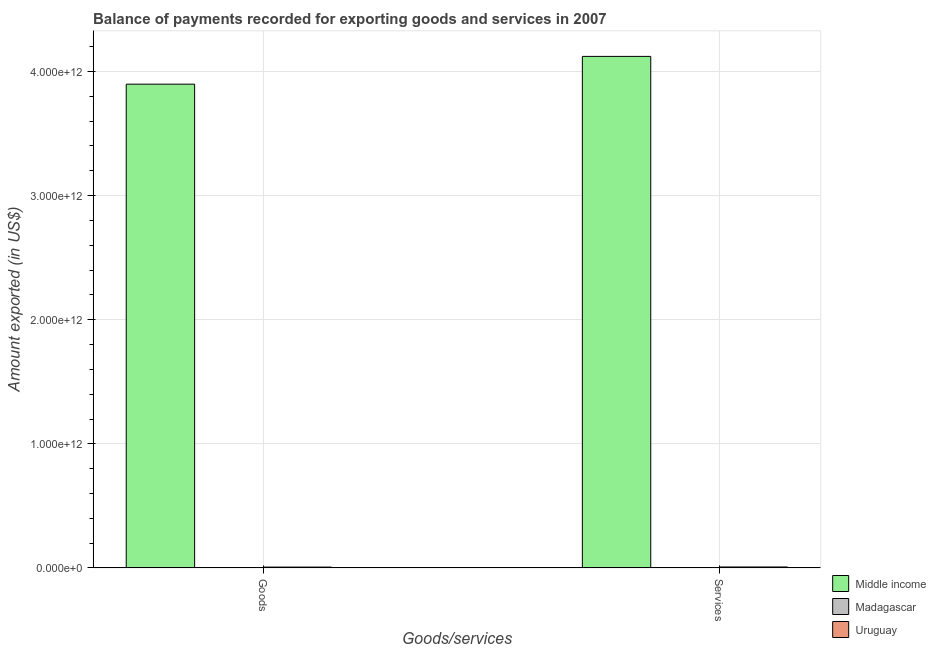How many groups of bars are there?
Your response must be concise. 2. Are the number of bars per tick equal to the number of legend labels?
Give a very brief answer. Yes. Are the number of bars on each tick of the X-axis equal?
Your answer should be very brief. Yes. How many bars are there on the 1st tick from the right?
Keep it short and to the point. 3. What is the label of the 1st group of bars from the left?
Your answer should be very brief. Goods. What is the amount of goods exported in Middle income?
Keep it short and to the point. 3.90e+12. Across all countries, what is the maximum amount of services exported?
Make the answer very short. 4.12e+12. Across all countries, what is the minimum amount of services exported?
Provide a short and direct response. 2.30e+09. In which country was the amount of goods exported maximum?
Your answer should be compact. Middle income. In which country was the amount of goods exported minimum?
Your answer should be compact. Madagascar. What is the total amount of goods exported in the graph?
Your response must be concise. 3.91e+12. What is the difference between the amount of goods exported in Uruguay and that in Middle income?
Your response must be concise. -3.89e+12. What is the difference between the amount of services exported in Middle income and the amount of goods exported in Madagascar?
Provide a short and direct response. 4.12e+12. What is the average amount of services exported per country?
Make the answer very short. 1.38e+12. What is the difference between the amount of services exported and amount of goods exported in Madagascar?
Provide a short and direct response. 5.18e+07. In how many countries, is the amount of goods exported greater than 2800000000000 US$?
Give a very brief answer. 1. What is the ratio of the amount of services exported in Madagascar to that in Uruguay?
Offer a very short reply. 0.29. Is the amount of services exported in Middle income less than that in Madagascar?
Your response must be concise. No. In how many countries, is the amount of goods exported greater than the average amount of goods exported taken over all countries?
Make the answer very short. 1. What does the 1st bar from the left in Services represents?
Give a very brief answer. Middle income. What does the 2nd bar from the right in Goods represents?
Provide a succinct answer. Madagascar. How many countries are there in the graph?
Provide a short and direct response. 3. What is the difference between two consecutive major ticks on the Y-axis?
Keep it short and to the point. 1.00e+12. Are the values on the major ticks of Y-axis written in scientific E-notation?
Provide a succinct answer. Yes. Where does the legend appear in the graph?
Ensure brevity in your answer.  Bottom right. How many legend labels are there?
Your answer should be very brief. 3. What is the title of the graph?
Provide a short and direct response. Balance of payments recorded for exporting goods and services in 2007. What is the label or title of the X-axis?
Give a very brief answer. Goods/services. What is the label or title of the Y-axis?
Your answer should be very brief. Amount exported (in US$). What is the Amount exported (in US$) in Middle income in Goods?
Give a very brief answer. 3.90e+12. What is the Amount exported (in US$) of Madagascar in Goods?
Offer a terse response. 2.24e+09. What is the Amount exported (in US$) of Uruguay in Goods?
Your answer should be compact. 6.93e+09. What is the Amount exported (in US$) of Middle income in Services?
Ensure brevity in your answer.  4.12e+12. What is the Amount exported (in US$) of Madagascar in Services?
Your answer should be very brief. 2.30e+09. What is the Amount exported (in US$) of Uruguay in Services?
Offer a terse response. 7.82e+09. Across all Goods/services, what is the maximum Amount exported (in US$) of Middle income?
Provide a succinct answer. 4.12e+12. Across all Goods/services, what is the maximum Amount exported (in US$) of Madagascar?
Provide a short and direct response. 2.30e+09. Across all Goods/services, what is the maximum Amount exported (in US$) of Uruguay?
Give a very brief answer. 7.82e+09. Across all Goods/services, what is the minimum Amount exported (in US$) of Middle income?
Keep it short and to the point. 3.90e+12. Across all Goods/services, what is the minimum Amount exported (in US$) of Madagascar?
Your response must be concise. 2.24e+09. Across all Goods/services, what is the minimum Amount exported (in US$) in Uruguay?
Offer a terse response. 6.93e+09. What is the total Amount exported (in US$) in Middle income in the graph?
Offer a very short reply. 8.02e+12. What is the total Amount exported (in US$) of Madagascar in the graph?
Provide a succinct answer. 4.54e+09. What is the total Amount exported (in US$) of Uruguay in the graph?
Offer a terse response. 1.48e+1. What is the difference between the Amount exported (in US$) of Middle income in Goods and that in Services?
Offer a very short reply. -2.24e+11. What is the difference between the Amount exported (in US$) of Madagascar in Goods and that in Services?
Make the answer very short. -5.18e+07. What is the difference between the Amount exported (in US$) in Uruguay in Goods and that in Services?
Offer a terse response. -8.85e+08. What is the difference between the Amount exported (in US$) of Middle income in Goods and the Amount exported (in US$) of Madagascar in Services?
Your answer should be very brief. 3.90e+12. What is the difference between the Amount exported (in US$) of Middle income in Goods and the Amount exported (in US$) of Uruguay in Services?
Provide a succinct answer. 3.89e+12. What is the difference between the Amount exported (in US$) in Madagascar in Goods and the Amount exported (in US$) in Uruguay in Services?
Provide a succinct answer. -5.57e+09. What is the average Amount exported (in US$) of Middle income per Goods/services?
Provide a succinct answer. 4.01e+12. What is the average Amount exported (in US$) in Madagascar per Goods/services?
Your answer should be compact. 2.27e+09. What is the average Amount exported (in US$) of Uruguay per Goods/services?
Give a very brief answer. 7.38e+09. What is the difference between the Amount exported (in US$) in Middle income and Amount exported (in US$) in Madagascar in Goods?
Your response must be concise. 3.90e+12. What is the difference between the Amount exported (in US$) of Middle income and Amount exported (in US$) of Uruguay in Goods?
Make the answer very short. 3.89e+12. What is the difference between the Amount exported (in US$) of Madagascar and Amount exported (in US$) of Uruguay in Goods?
Your answer should be very brief. -4.69e+09. What is the difference between the Amount exported (in US$) in Middle income and Amount exported (in US$) in Madagascar in Services?
Keep it short and to the point. 4.12e+12. What is the difference between the Amount exported (in US$) in Middle income and Amount exported (in US$) in Uruguay in Services?
Make the answer very short. 4.11e+12. What is the difference between the Amount exported (in US$) of Madagascar and Amount exported (in US$) of Uruguay in Services?
Your answer should be compact. -5.52e+09. What is the ratio of the Amount exported (in US$) of Middle income in Goods to that in Services?
Make the answer very short. 0.95. What is the ratio of the Amount exported (in US$) in Madagascar in Goods to that in Services?
Ensure brevity in your answer.  0.98. What is the ratio of the Amount exported (in US$) of Uruguay in Goods to that in Services?
Your answer should be very brief. 0.89. What is the difference between the highest and the second highest Amount exported (in US$) of Middle income?
Provide a succinct answer. 2.24e+11. What is the difference between the highest and the second highest Amount exported (in US$) in Madagascar?
Provide a succinct answer. 5.18e+07. What is the difference between the highest and the second highest Amount exported (in US$) in Uruguay?
Make the answer very short. 8.85e+08. What is the difference between the highest and the lowest Amount exported (in US$) of Middle income?
Give a very brief answer. 2.24e+11. What is the difference between the highest and the lowest Amount exported (in US$) of Madagascar?
Ensure brevity in your answer.  5.18e+07. What is the difference between the highest and the lowest Amount exported (in US$) in Uruguay?
Your answer should be compact. 8.85e+08. 